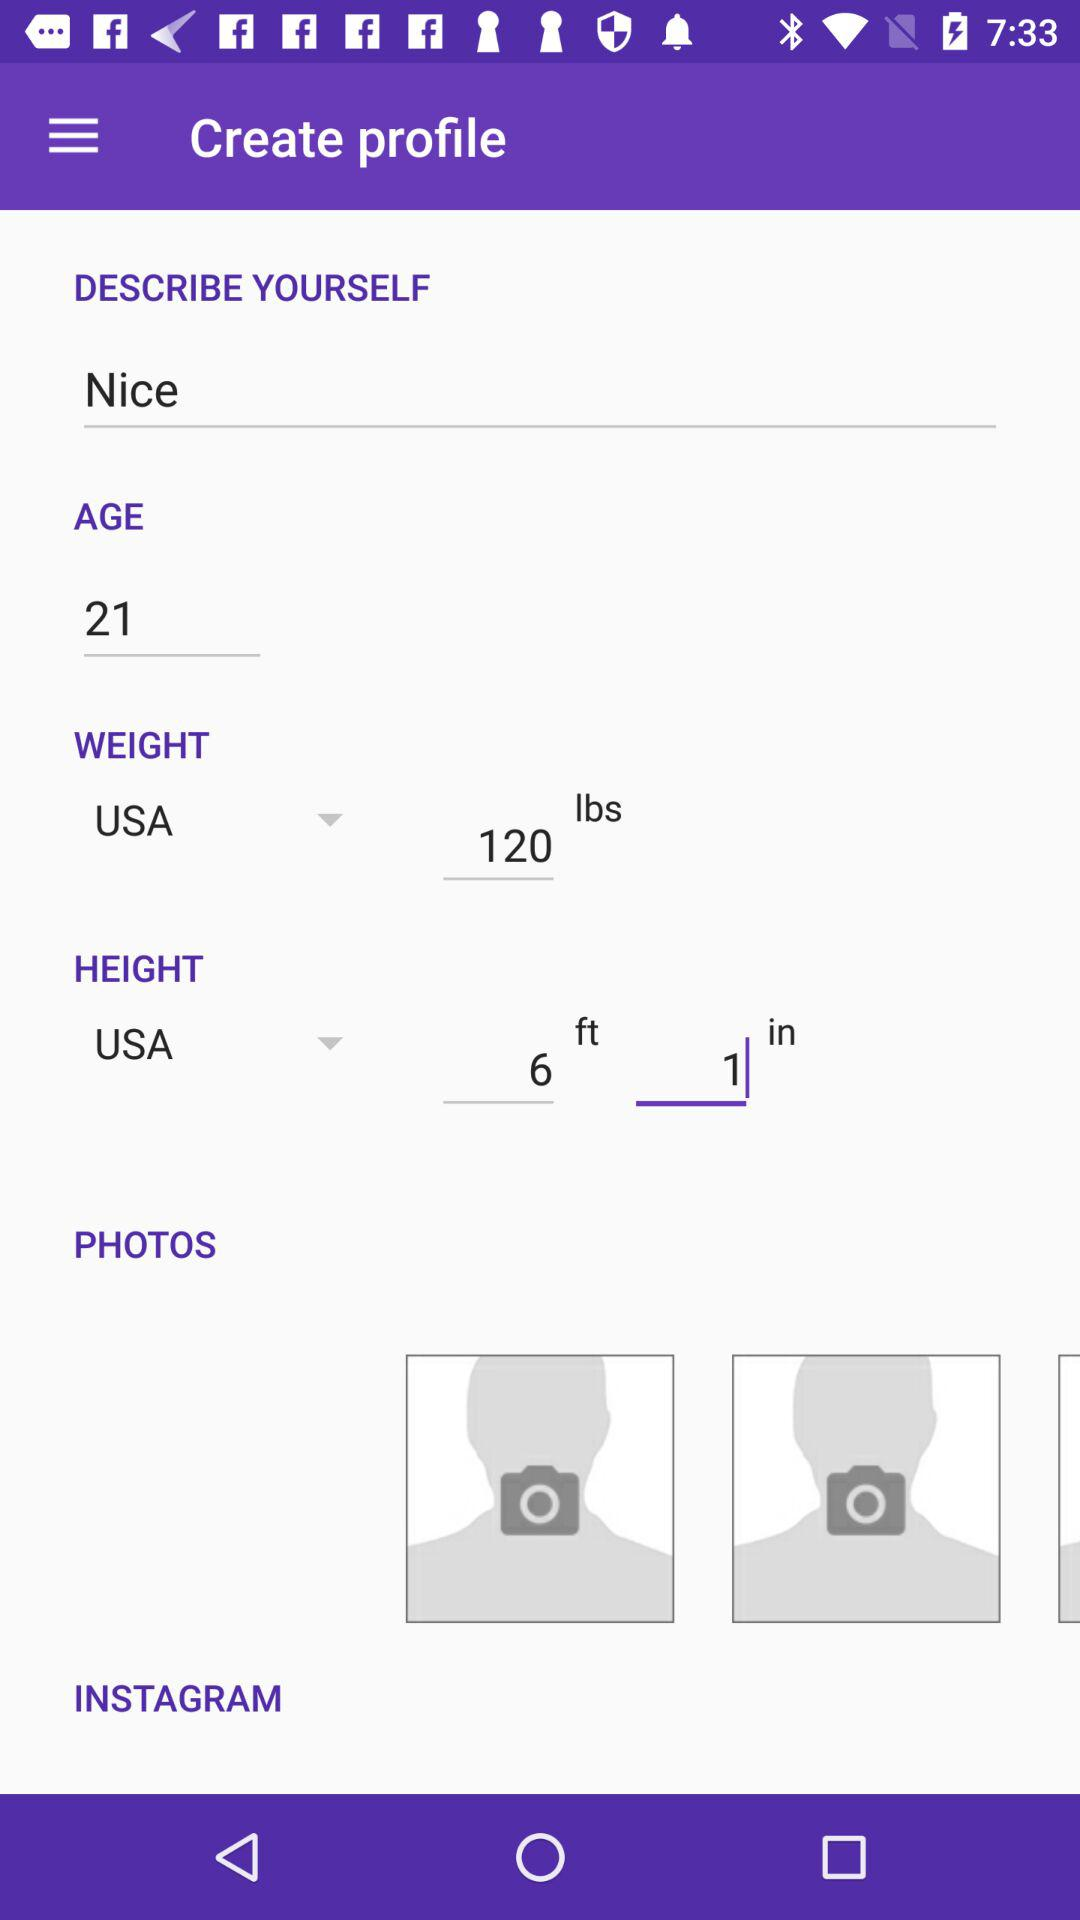What's the user age? The user age is 21. 